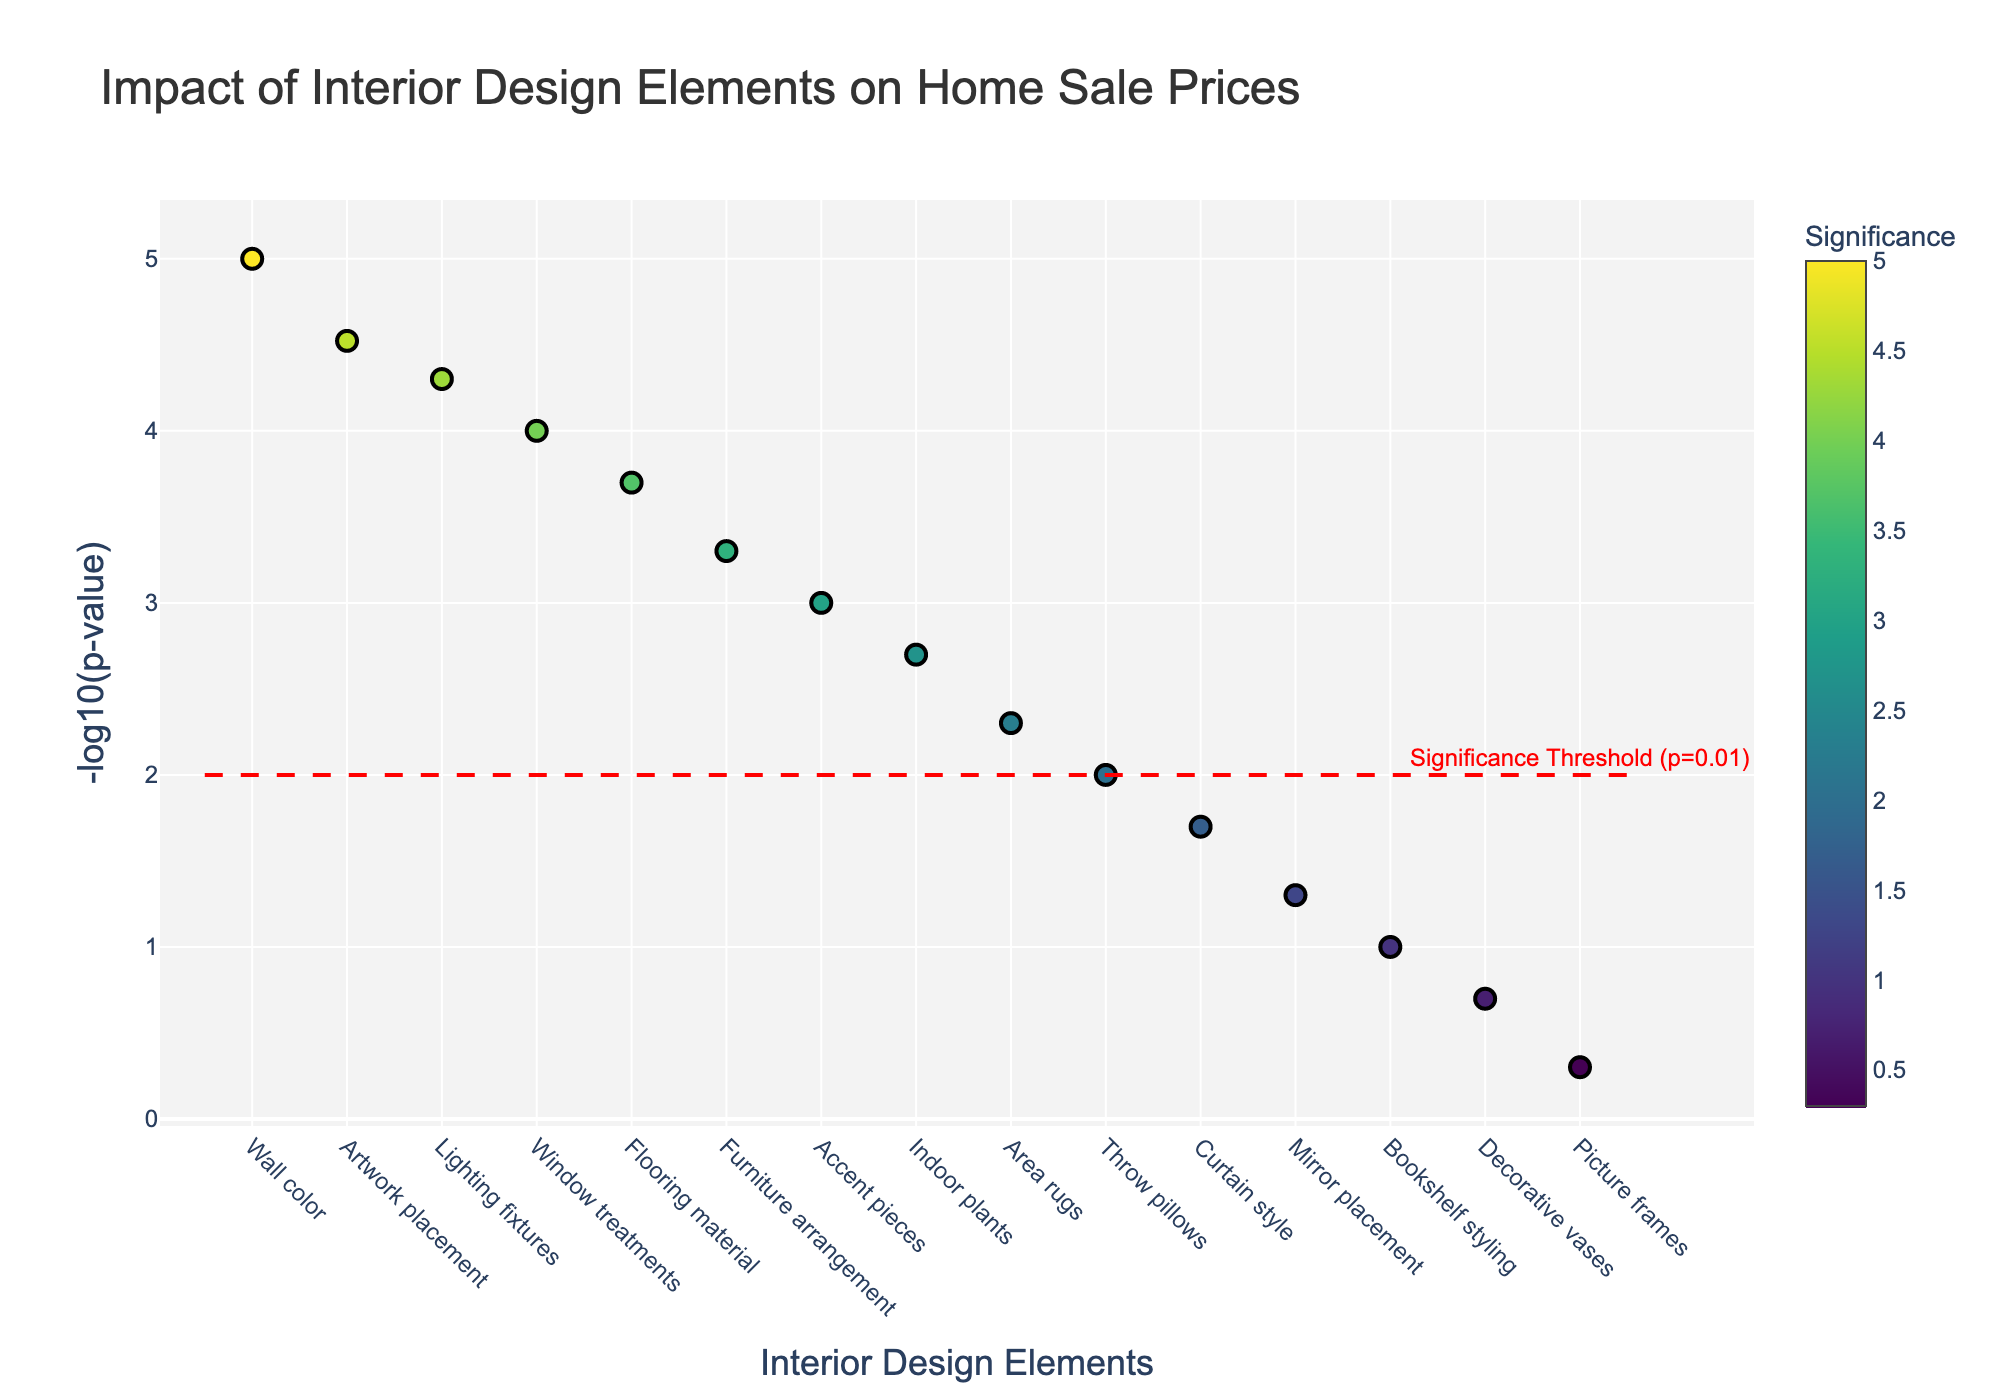What is the title of the plot? The title of the plot is located at the top and clearly states the main focus.
Answer: Impact of Interior Design Elements on Home Sale Prices How many interior elements have a p-value lower than the significance threshold (p=0.01)? Look at the horizontal red dashed line indicating the significance threshold (at y=2). Count the number of points above this line.
Answer: 9 Which interior design element has the lowest p-value on the plot? Find the point on the plot that is the highest on the y-axis (since -log10(p-value) is larger for smaller p-values).
Answer: Wall color What does the y-axis represent? The label on the y-axis specifies what is being measured.
Answer: -log10(p-value) Compare the significance of Artwork placement and Indoor plants. Which one has higher significance? Locate both data points and compare their y-values (higher y-value means higher significance).
Answer: Artwork placement What does the significance scale indicate in the plot? The color gradient bar (viridis color scale) on the right side of the plot shows the relationship between color and significance.
Answer: The relative level of significance for each interior element What is the y-value of the red dashed horizontal line and what does it represent? Observe the y-coordinate where the red dashed line is located and read the annotation close to it.
Answer: 2, represents p-value = 0.01 If the p-value for Throw pillows is 0.01, what is its corresponding value on the y-axis? Use the formula -log10(p_value), where p_value for Throw pillows is 0.01. Compute -log10(0.01) to find the y-coordinate.
Answer: 2 Which interior elements have significance values closest to the threshold (p=0.01)? Identify the elements whose p-values are close to 0.01 (just above or just below the threshold), and check their y-values around 2.
Answer: Throw pillows and Indoor plants What inference can you make about the impact of Wall color compared to Mirror placement on home sale prices? Compare the positions of Wall color and Mirror placement points on the y-axis; Wall color has a higher y-value indicating a smaller p-value.
Answer: Wall color has a much higher impact than Mirror placement 